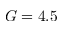Convert formula to latex. <formula><loc_0><loc_0><loc_500><loc_500>G = 4 . 5</formula> 